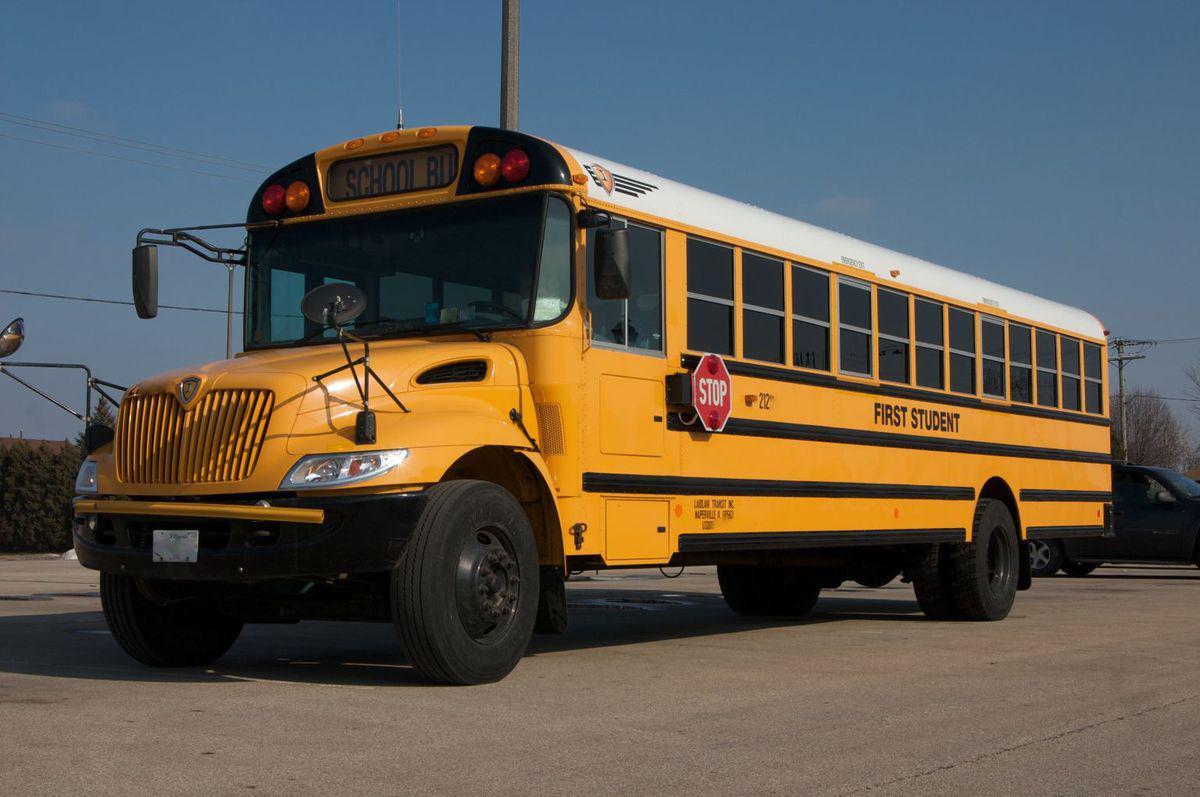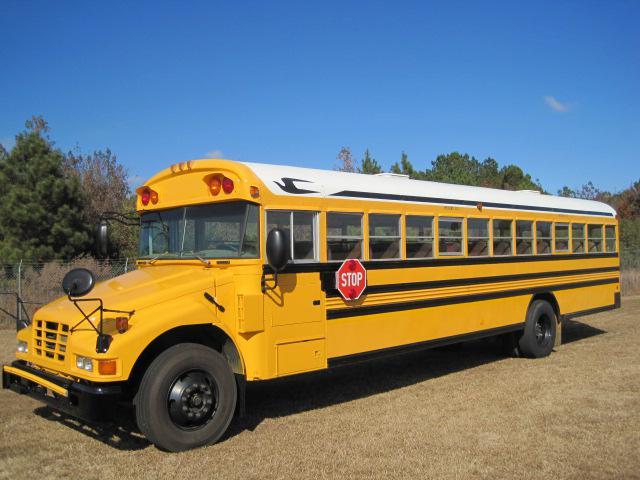The first image is the image on the left, the second image is the image on the right. Examine the images to the left and right. Is the description "Each image contains one bus that has a non-flat front and is parked at a leftward angle, with the red sign on its side facing the camera." accurate? Answer yes or no. Yes. The first image is the image on the left, the second image is the image on the right. For the images shown, is this caption "Every school bus is pointing to the left." true? Answer yes or no. Yes. 